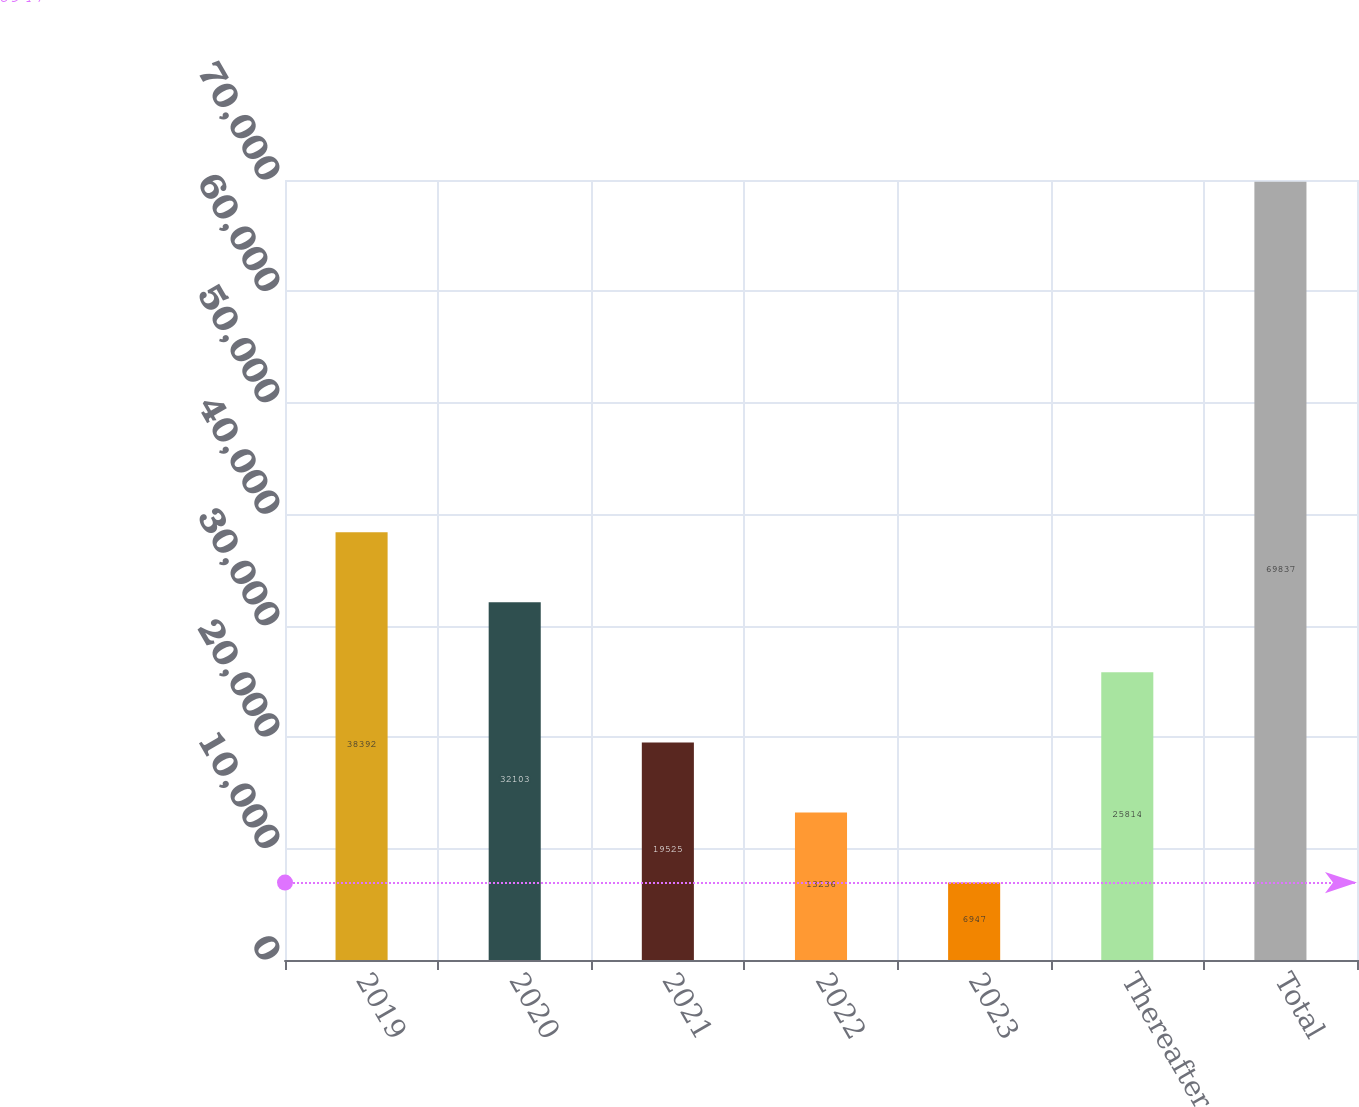Convert chart to OTSL. <chart><loc_0><loc_0><loc_500><loc_500><bar_chart><fcel>2019<fcel>2020<fcel>2021<fcel>2022<fcel>2023<fcel>Thereafter<fcel>Total<nl><fcel>38392<fcel>32103<fcel>19525<fcel>13236<fcel>6947<fcel>25814<fcel>69837<nl></chart> 